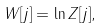Convert formula to latex. <formula><loc_0><loc_0><loc_500><loc_500>W [ j ] = \ln Z [ j ] ,</formula> 